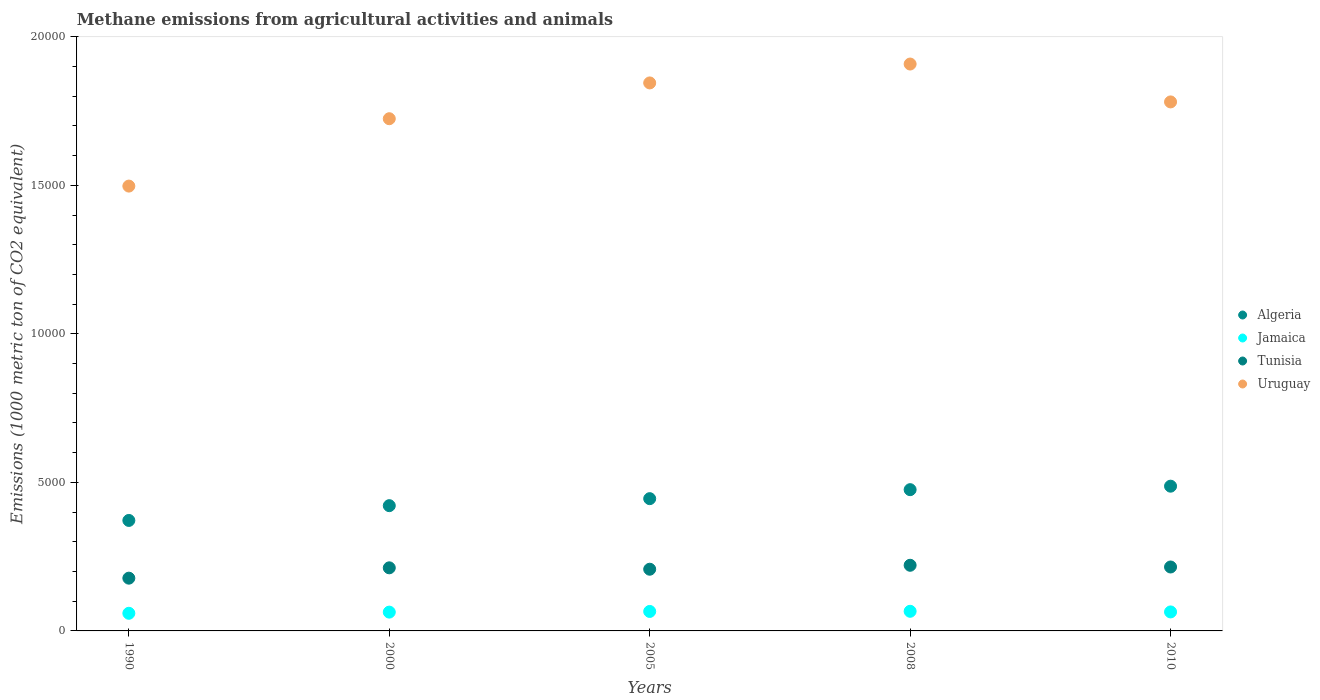What is the amount of methane emitted in Tunisia in 2010?
Offer a very short reply. 2151.9. Across all years, what is the maximum amount of methane emitted in Algeria?
Ensure brevity in your answer.  4872.2. Across all years, what is the minimum amount of methane emitted in Jamaica?
Your response must be concise. 593.6. In which year was the amount of methane emitted in Algeria maximum?
Ensure brevity in your answer.  2010. In which year was the amount of methane emitted in Algeria minimum?
Give a very brief answer. 1990. What is the total amount of methane emitted in Jamaica in the graph?
Provide a succinct answer. 3182.2. What is the difference between the amount of methane emitted in Algeria in 1990 and that in 2005?
Give a very brief answer. -733.2. What is the difference between the amount of methane emitted in Tunisia in 2005 and the amount of methane emitted in Jamaica in 2010?
Your answer should be very brief. 1437.5. What is the average amount of methane emitted in Tunisia per year?
Your answer should be very brief. 2067.6. In the year 1990, what is the difference between the amount of methane emitted in Algeria and amount of methane emitted in Uruguay?
Offer a very short reply. -1.13e+04. What is the ratio of the amount of methane emitted in Algeria in 1990 to that in 2005?
Offer a terse response. 0.84. Is the difference between the amount of methane emitted in Algeria in 2000 and 2010 greater than the difference between the amount of methane emitted in Uruguay in 2000 and 2010?
Provide a short and direct response. No. What is the difference between the highest and the second highest amount of methane emitted in Uruguay?
Keep it short and to the point. 635.7. What is the difference between the highest and the lowest amount of methane emitted in Jamaica?
Offer a very short reply. 67.2. In how many years, is the amount of methane emitted in Uruguay greater than the average amount of methane emitted in Uruguay taken over all years?
Provide a succinct answer. 3. Is it the case that in every year, the sum of the amount of methane emitted in Tunisia and amount of methane emitted in Jamaica  is greater than the sum of amount of methane emitted in Uruguay and amount of methane emitted in Algeria?
Your answer should be compact. No. Does the amount of methane emitted in Jamaica monotonically increase over the years?
Offer a very short reply. No. How many years are there in the graph?
Offer a terse response. 5. Does the graph contain grids?
Provide a succinct answer. No. Where does the legend appear in the graph?
Your response must be concise. Center right. How are the legend labels stacked?
Provide a short and direct response. Vertical. What is the title of the graph?
Give a very brief answer. Methane emissions from agricultural activities and animals. What is the label or title of the X-axis?
Keep it short and to the point. Years. What is the label or title of the Y-axis?
Ensure brevity in your answer.  Emissions (1000 metric ton of CO2 equivalent). What is the Emissions (1000 metric ton of CO2 equivalent) in Algeria in 1990?
Your response must be concise. 3718.9. What is the Emissions (1000 metric ton of CO2 equivalent) in Jamaica in 1990?
Ensure brevity in your answer.  593.6. What is the Emissions (1000 metric ton of CO2 equivalent) in Tunisia in 1990?
Offer a terse response. 1775.7. What is the Emissions (1000 metric ton of CO2 equivalent) in Uruguay in 1990?
Make the answer very short. 1.50e+04. What is the Emissions (1000 metric ton of CO2 equivalent) of Algeria in 2000?
Your answer should be compact. 4216.3. What is the Emissions (1000 metric ton of CO2 equivalent) of Jamaica in 2000?
Give a very brief answer. 632.9. What is the Emissions (1000 metric ton of CO2 equivalent) of Tunisia in 2000?
Make the answer very short. 2123.8. What is the Emissions (1000 metric ton of CO2 equivalent) in Uruguay in 2000?
Keep it short and to the point. 1.72e+04. What is the Emissions (1000 metric ton of CO2 equivalent) of Algeria in 2005?
Offer a very short reply. 4452.1. What is the Emissions (1000 metric ton of CO2 equivalent) in Jamaica in 2005?
Provide a succinct answer. 655.6. What is the Emissions (1000 metric ton of CO2 equivalent) of Tunisia in 2005?
Provide a succinct answer. 2076.8. What is the Emissions (1000 metric ton of CO2 equivalent) in Uruguay in 2005?
Give a very brief answer. 1.84e+04. What is the Emissions (1000 metric ton of CO2 equivalent) in Algeria in 2008?
Provide a short and direct response. 4754.7. What is the Emissions (1000 metric ton of CO2 equivalent) in Jamaica in 2008?
Your answer should be compact. 660.8. What is the Emissions (1000 metric ton of CO2 equivalent) in Tunisia in 2008?
Ensure brevity in your answer.  2209.8. What is the Emissions (1000 metric ton of CO2 equivalent) of Uruguay in 2008?
Provide a succinct answer. 1.91e+04. What is the Emissions (1000 metric ton of CO2 equivalent) in Algeria in 2010?
Offer a terse response. 4872.2. What is the Emissions (1000 metric ton of CO2 equivalent) in Jamaica in 2010?
Offer a terse response. 639.3. What is the Emissions (1000 metric ton of CO2 equivalent) in Tunisia in 2010?
Your answer should be very brief. 2151.9. What is the Emissions (1000 metric ton of CO2 equivalent) in Uruguay in 2010?
Provide a succinct answer. 1.78e+04. Across all years, what is the maximum Emissions (1000 metric ton of CO2 equivalent) of Algeria?
Provide a succinct answer. 4872.2. Across all years, what is the maximum Emissions (1000 metric ton of CO2 equivalent) in Jamaica?
Give a very brief answer. 660.8. Across all years, what is the maximum Emissions (1000 metric ton of CO2 equivalent) in Tunisia?
Give a very brief answer. 2209.8. Across all years, what is the maximum Emissions (1000 metric ton of CO2 equivalent) of Uruguay?
Offer a terse response. 1.91e+04. Across all years, what is the minimum Emissions (1000 metric ton of CO2 equivalent) in Algeria?
Keep it short and to the point. 3718.9. Across all years, what is the minimum Emissions (1000 metric ton of CO2 equivalent) in Jamaica?
Keep it short and to the point. 593.6. Across all years, what is the minimum Emissions (1000 metric ton of CO2 equivalent) of Tunisia?
Your answer should be compact. 1775.7. Across all years, what is the minimum Emissions (1000 metric ton of CO2 equivalent) of Uruguay?
Provide a short and direct response. 1.50e+04. What is the total Emissions (1000 metric ton of CO2 equivalent) of Algeria in the graph?
Offer a very short reply. 2.20e+04. What is the total Emissions (1000 metric ton of CO2 equivalent) in Jamaica in the graph?
Provide a succinct answer. 3182.2. What is the total Emissions (1000 metric ton of CO2 equivalent) of Tunisia in the graph?
Your answer should be very brief. 1.03e+04. What is the total Emissions (1000 metric ton of CO2 equivalent) of Uruguay in the graph?
Provide a short and direct response. 8.75e+04. What is the difference between the Emissions (1000 metric ton of CO2 equivalent) of Algeria in 1990 and that in 2000?
Ensure brevity in your answer.  -497.4. What is the difference between the Emissions (1000 metric ton of CO2 equivalent) of Jamaica in 1990 and that in 2000?
Provide a short and direct response. -39.3. What is the difference between the Emissions (1000 metric ton of CO2 equivalent) in Tunisia in 1990 and that in 2000?
Your answer should be compact. -348.1. What is the difference between the Emissions (1000 metric ton of CO2 equivalent) of Uruguay in 1990 and that in 2000?
Ensure brevity in your answer.  -2267.7. What is the difference between the Emissions (1000 metric ton of CO2 equivalent) in Algeria in 1990 and that in 2005?
Make the answer very short. -733.2. What is the difference between the Emissions (1000 metric ton of CO2 equivalent) of Jamaica in 1990 and that in 2005?
Keep it short and to the point. -62. What is the difference between the Emissions (1000 metric ton of CO2 equivalent) in Tunisia in 1990 and that in 2005?
Your answer should be very brief. -301.1. What is the difference between the Emissions (1000 metric ton of CO2 equivalent) of Uruguay in 1990 and that in 2005?
Your answer should be very brief. -3472.5. What is the difference between the Emissions (1000 metric ton of CO2 equivalent) in Algeria in 1990 and that in 2008?
Give a very brief answer. -1035.8. What is the difference between the Emissions (1000 metric ton of CO2 equivalent) of Jamaica in 1990 and that in 2008?
Provide a succinct answer. -67.2. What is the difference between the Emissions (1000 metric ton of CO2 equivalent) in Tunisia in 1990 and that in 2008?
Offer a terse response. -434.1. What is the difference between the Emissions (1000 metric ton of CO2 equivalent) in Uruguay in 1990 and that in 2008?
Offer a terse response. -4108.2. What is the difference between the Emissions (1000 metric ton of CO2 equivalent) in Algeria in 1990 and that in 2010?
Keep it short and to the point. -1153.3. What is the difference between the Emissions (1000 metric ton of CO2 equivalent) in Jamaica in 1990 and that in 2010?
Give a very brief answer. -45.7. What is the difference between the Emissions (1000 metric ton of CO2 equivalent) in Tunisia in 1990 and that in 2010?
Make the answer very short. -376.2. What is the difference between the Emissions (1000 metric ton of CO2 equivalent) in Uruguay in 1990 and that in 2010?
Provide a short and direct response. -2833.1. What is the difference between the Emissions (1000 metric ton of CO2 equivalent) of Algeria in 2000 and that in 2005?
Keep it short and to the point. -235.8. What is the difference between the Emissions (1000 metric ton of CO2 equivalent) of Jamaica in 2000 and that in 2005?
Your response must be concise. -22.7. What is the difference between the Emissions (1000 metric ton of CO2 equivalent) in Tunisia in 2000 and that in 2005?
Keep it short and to the point. 47. What is the difference between the Emissions (1000 metric ton of CO2 equivalent) in Uruguay in 2000 and that in 2005?
Keep it short and to the point. -1204.8. What is the difference between the Emissions (1000 metric ton of CO2 equivalent) in Algeria in 2000 and that in 2008?
Your response must be concise. -538.4. What is the difference between the Emissions (1000 metric ton of CO2 equivalent) in Jamaica in 2000 and that in 2008?
Offer a very short reply. -27.9. What is the difference between the Emissions (1000 metric ton of CO2 equivalent) in Tunisia in 2000 and that in 2008?
Offer a terse response. -86. What is the difference between the Emissions (1000 metric ton of CO2 equivalent) of Uruguay in 2000 and that in 2008?
Provide a short and direct response. -1840.5. What is the difference between the Emissions (1000 metric ton of CO2 equivalent) of Algeria in 2000 and that in 2010?
Give a very brief answer. -655.9. What is the difference between the Emissions (1000 metric ton of CO2 equivalent) in Jamaica in 2000 and that in 2010?
Your response must be concise. -6.4. What is the difference between the Emissions (1000 metric ton of CO2 equivalent) of Tunisia in 2000 and that in 2010?
Offer a terse response. -28.1. What is the difference between the Emissions (1000 metric ton of CO2 equivalent) of Uruguay in 2000 and that in 2010?
Ensure brevity in your answer.  -565.4. What is the difference between the Emissions (1000 metric ton of CO2 equivalent) of Algeria in 2005 and that in 2008?
Ensure brevity in your answer.  -302.6. What is the difference between the Emissions (1000 metric ton of CO2 equivalent) in Tunisia in 2005 and that in 2008?
Make the answer very short. -133. What is the difference between the Emissions (1000 metric ton of CO2 equivalent) of Uruguay in 2005 and that in 2008?
Your response must be concise. -635.7. What is the difference between the Emissions (1000 metric ton of CO2 equivalent) in Algeria in 2005 and that in 2010?
Offer a terse response. -420.1. What is the difference between the Emissions (1000 metric ton of CO2 equivalent) in Jamaica in 2005 and that in 2010?
Provide a succinct answer. 16.3. What is the difference between the Emissions (1000 metric ton of CO2 equivalent) of Tunisia in 2005 and that in 2010?
Offer a very short reply. -75.1. What is the difference between the Emissions (1000 metric ton of CO2 equivalent) in Uruguay in 2005 and that in 2010?
Give a very brief answer. 639.4. What is the difference between the Emissions (1000 metric ton of CO2 equivalent) in Algeria in 2008 and that in 2010?
Offer a terse response. -117.5. What is the difference between the Emissions (1000 metric ton of CO2 equivalent) in Tunisia in 2008 and that in 2010?
Keep it short and to the point. 57.9. What is the difference between the Emissions (1000 metric ton of CO2 equivalent) of Uruguay in 2008 and that in 2010?
Your answer should be very brief. 1275.1. What is the difference between the Emissions (1000 metric ton of CO2 equivalent) in Algeria in 1990 and the Emissions (1000 metric ton of CO2 equivalent) in Jamaica in 2000?
Give a very brief answer. 3086. What is the difference between the Emissions (1000 metric ton of CO2 equivalent) in Algeria in 1990 and the Emissions (1000 metric ton of CO2 equivalent) in Tunisia in 2000?
Make the answer very short. 1595.1. What is the difference between the Emissions (1000 metric ton of CO2 equivalent) of Algeria in 1990 and the Emissions (1000 metric ton of CO2 equivalent) of Uruguay in 2000?
Offer a terse response. -1.35e+04. What is the difference between the Emissions (1000 metric ton of CO2 equivalent) in Jamaica in 1990 and the Emissions (1000 metric ton of CO2 equivalent) in Tunisia in 2000?
Provide a short and direct response. -1530.2. What is the difference between the Emissions (1000 metric ton of CO2 equivalent) of Jamaica in 1990 and the Emissions (1000 metric ton of CO2 equivalent) of Uruguay in 2000?
Your answer should be very brief. -1.66e+04. What is the difference between the Emissions (1000 metric ton of CO2 equivalent) of Tunisia in 1990 and the Emissions (1000 metric ton of CO2 equivalent) of Uruguay in 2000?
Offer a terse response. -1.55e+04. What is the difference between the Emissions (1000 metric ton of CO2 equivalent) in Algeria in 1990 and the Emissions (1000 metric ton of CO2 equivalent) in Jamaica in 2005?
Your answer should be very brief. 3063.3. What is the difference between the Emissions (1000 metric ton of CO2 equivalent) in Algeria in 1990 and the Emissions (1000 metric ton of CO2 equivalent) in Tunisia in 2005?
Your response must be concise. 1642.1. What is the difference between the Emissions (1000 metric ton of CO2 equivalent) of Algeria in 1990 and the Emissions (1000 metric ton of CO2 equivalent) of Uruguay in 2005?
Provide a succinct answer. -1.47e+04. What is the difference between the Emissions (1000 metric ton of CO2 equivalent) in Jamaica in 1990 and the Emissions (1000 metric ton of CO2 equivalent) in Tunisia in 2005?
Give a very brief answer. -1483.2. What is the difference between the Emissions (1000 metric ton of CO2 equivalent) in Jamaica in 1990 and the Emissions (1000 metric ton of CO2 equivalent) in Uruguay in 2005?
Your answer should be very brief. -1.79e+04. What is the difference between the Emissions (1000 metric ton of CO2 equivalent) of Tunisia in 1990 and the Emissions (1000 metric ton of CO2 equivalent) of Uruguay in 2005?
Provide a short and direct response. -1.67e+04. What is the difference between the Emissions (1000 metric ton of CO2 equivalent) in Algeria in 1990 and the Emissions (1000 metric ton of CO2 equivalent) in Jamaica in 2008?
Provide a short and direct response. 3058.1. What is the difference between the Emissions (1000 metric ton of CO2 equivalent) of Algeria in 1990 and the Emissions (1000 metric ton of CO2 equivalent) of Tunisia in 2008?
Your answer should be compact. 1509.1. What is the difference between the Emissions (1000 metric ton of CO2 equivalent) of Algeria in 1990 and the Emissions (1000 metric ton of CO2 equivalent) of Uruguay in 2008?
Your response must be concise. -1.54e+04. What is the difference between the Emissions (1000 metric ton of CO2 equivalent) of Jamaica in 1990 and the Emissions (1000 metric ton of CO2 equivalent) of Tunisia in 2008?
Offer a very short reply. -1616.2. What is the difference between the Emissions (1000 metric ton of CO2 equivalent) in Jamaica in 1990 and the Emissions (1000 metric ton of CO2 equivalent) in Uruguay in 2008?
Give a very brief answer. -1.85e+04. What is the difference between the Emissions (1000 metric ton of CO2 equivalent) in Tunisia in 1990 and the Emissions (1000 metric ton of CO2 equivalent) in Uruguay in 2008?
Your response must be concise. -1.73e+04. What is the difference between the Emissions (1000 metric ton of CO2 equivalent) in Algeria in 1990 and the Emissions (1000 metric ton of CO2 equivalent) in Jamaica in 2010?
Make the answer very short. 3079.6. What is the difference between the Emissions (1000 metric ton of CO2 equivalent) of Algeria in 1990 and the Emissions (1000 metric ton of CO2 equivalent) of Tunisia in 2010?
Your answer should be compact. 1567. What is the difference between the Emissions (1000 metric ton of CO2 equivalent) of Algeria in 1990 and the Emissions (1000 metric ton of CO2 equivalent) of Uruguay in 2010?
Provide a succinct answer. -1.41e+04. What is the difference between the Emissions (1000 metric ton of CO2 equivalent) in Jamaica in 1990 and the Emissions (1000 metric ton of CO2 equivalent) in Tunisia in 2010?
Your answer should be compact. -1558.3. What is the difference between the Emissions (1000 metric ton of CO2 equivalent) of Jamaica in 1990 and the Emissions (1000 metric ton of CO2 equivalent) of Uruguay in 2010?
Your answer should be compact. -1.72e+04. What is the difference between the Emissions (1000 metric ton of CO2 equivalent) in Tunisia in 1990 and the Emissions (1000 metric ton of CO2 equivalent) in Uruguay in 2010?
Your response must be concise. -1.60e+04. What is the difference between the Emissions (1000 metric ton of CO2 equivalent) of Algeria in 2000 and the Emissions (1000 metric ton of CO2 equivalent) of Jamaica in 2005?
Make the answer very short. 3560.7. What is the difference between the Emissions (1000 metric ton of CO2 equivalent) of Algeria in 2000 and the Emissions (1000 metric ton of CO2 equivalent) of Tunisia in 2005?
Your answer should be compact. 2139.5. What is the difference between the Emissions (1000 metric ton of CO2 equivalent) in Algeria in 2000 and the Emissions (1000 metric ton of CO2 equivalent) in Uruguay in 2005?
Give a very brief answer. -1.42e+04. What is the difference between the Emissions (1000 metric ton of CO2 equivalent) in Jamaica in 2000 and the Emissions (1000 metric ton of CO2 equivalent) in Tunisia in 2005?
Offer a terse response. -1443.9. What is the difference between the Emissions (1000 metric ton of CO2 equivalent) in Jamaica in 2000 and the Emissions (1000 metric ton of CO2 equivalent) in Uruguay in 2005?
Offer a terse response. -1.78e+04. What is the difference between the Emissions (1000 metric ton of CO2 equivalent) of Tunisia in 2000 and the Emissions (1000 metric ton of CO2 equivalent) of Uruguay in 2005?
Make the answer very short. -1.63e+04. What is the difference between the Emissions (1000 metric ton of CO2 equivalent) of Algeria in 2000 and the Emissions (1000 metric ton of CO2 equivalent) of Jamaica in 2008?
Your answer should be very brief. 3555.5. What is the difference between the Emissions (1000 metric ton of CO2 equivalent) of Algeria in 2000 and the Emissions (1000 metric ton of CO2 equivalent) of Tunisia in 2008?
Offer a very short reply. 2006.5. What is the difference between the Emissions (1000 metric ton of CO2 equivalent) in Algeria in 2000 and the Emissions (1000 metric ton of CO2 equivalent) in Uruguay in 2008?
Offer a very short reply. -1.49e+04. What is the difference between the Emissions (1000 metric ton of CO2 equivalent) of Jamaica in 2000 and the Emissions (1000 metric ton of CO2 equivalent) of Tunisia in 2008?
Give a very brief answer. -1576.9. What is the difference between the Emissions (1000 metric ton of CO2 equivalent) in Jamaica in 2000 and the Emissions (1000 metric ton of CO2 equivalent) in Uruguay in 2008?
Keep it short and to the point. -1.84e+04. What is the difference between the Emissions (1000 metric ton of CO2 equivalent) in Tunisia in 2000 and the Emissions (1000 metric ton of CO2 equivalent) in Uruguay in 2008?
Give a very brief answer. -1.70e+04. What is the difference between the Emissions (1000 metric ton of CO2 equivalent) in Algeria in 2000 and the Emissions (1000 metric ton of CO2 equivalent) in Jamaica in 2010?
Provide a succinct answer. 3577. What is the difference between the Emissions (1000 metric ton of CO2 equivalent) of Algeria in 2000 and the Emissions (1000 metric ton of CO2 equivalent) of Tunisia in 2010?
Provide a short and direct response. 2064.4. What is the difference between the Emissions (1000 metric ton of CO2 equivalent) in Algeria in 2000 and the Emissions (1000 metric ton of CO2 equivalent) in Uruguay in 2010?
Offer a very short reply. -1.36e+04. What is the difference between the Emissions (1000 metric ton of CO2 equivalent) in Jamaica in 2000 and the Emissions (1000 metric ton of CO2 equivalent) in Tunisia in 2010?
Ensure brevity in your answer.  -1519. What is the difference between the Emissions (1000 metric ton of CO2 equivalent) in Jamaica in 2000 and the Emissions (1000 metric ton of CO2 equivalent) in Uruguay in 2010?
Provide a succinct answer. -1.72e+04. What is the difference between the Emissions (1000 metric ton of CO2 equivalent) of Tunisia in 2000 and the Emissions (1000 metric ton of CO2 equivalent) of Uruguay in 2010?
Ensure brevity in your answer.  -1.57e+04. What is the difference between the Emissions (1000 metric ton of CO2 equivalent) of Algeria in 2005 and the Emissions (1000 metric ton of CO2 equivalent) of Jamaica in 2008?
Provide a succinct answer. 3791.3. What is the difference between the Emissions (1000 metric ton of CO2 equivalent) of Algeria in 2005 and the Emissions (1000 metric ton of CO2 equivalent) of Tunisia in 2008?
Your response must be concise. 2242.3. What is the difference between the Emissions (1000 metric ton of CO2 equivalent) in Algeria in 2005 and the Emissions (1000 metric ton of CO2 equivalent) in Uruguay in 2008?
Give a very brief answer. -1.46e+04. What is the difference between the Emissions (1000 metric ton of CO2 equivalent) of Jamaica in 2005 and the Emissions (1000 metric ton of CO2 equivalent) of Tunisia in 2008?
Your answer should be compact. -1554.2. What is the difference between the Emissions (1000 metric ton of CO2 equivalent) in Jamaica in 2005 and the Emissions (1000 metric ton of CO2 equivalent) in Uruguay in 2008?
Offer a terse response. -1.84e+04. What is the difference between the Emissions (1000 metric ton of CO2 equivalent) of Tunisia in 2005 and the Emissions (1000 metric ton of CO2 equivalent) of Uruguay in 2008?
Provide a short and direct response. -1.70e+04. What is the difference between the Emissions (1000 metric ton of CO2 equivalent) in Algeria in 2005 and the Emissions (1000 metric ton of CO2 equivalent) in Jamaica in 2010?
Offer a terse response. 3812.8. What is the difference between the Emissions (1000 metric ton of CO2 equivalent) in Algeria in 2005 and the Emissions (1000 metric ton of CO2 equivalent) in Tunisia in 2010?
Ensure brevity in your answer.  2300.2. What is the difference between the Emissions (1000 metric ton of CO2 equivalent) of Algeria in 2005 and the Emissions (1000 metric ton of CO2 equivalent) of Uruguay in 2010?
Provide a succinct answer. -1.34e+04. What is the difference between the Emissions (1000 metric ton of CO2 equivalent) in Jamaica in 2005 and the Emissions (1000 metric ton of CO2 equivalent) in Tunisia in 2010?
Ensure brevity in your answer.  -1496.3. What is the difference between the Emissions (1000 metric ton of CO2 equivalent) in Jamaica in 2005 and the Emissions (1000 metric ton of CO2 equivalent) in Uruguay in 2010?
Give a very brief answer. -1.72e+04. What is the difference between the Emissions (1000 metric ton of CO2 equivalent) of Tunisia in 2005 and the Emissions (1000 metric ton of CO2 equivalent) of Uruguay in 2010?
Make the answer very short. -1.57e+04. What is the difference between the Emissions (1000 metric ton of CO2 equivalent) in Algeria in 2008 and the Emissions (1000 metric ton of CO2 equivalent) in Jamaica in 2010?
Ensure brevity in your answer.  4115.4. What is the difference between the Emissions (1000 metric ton of CO2 equivalent) of Algeria in 2008 and the Emissions (1000 metric ton of CO2 equivalent) of Tunisia in 2010?
Provide a succinct answer. 2602.8. What is the difference between the Emissions (1000 metric ton of CO2 equivalent) in Algeria in 2008 and the Emissions (1000 metric ton of CO2 equivalent) in Uruguay in 2010?
Keep it short and to the point. -1.31e+04. What is the difference between the Emissions (1000 metric ton of CO2 equivalent) in Jamaica in 2008 and the Emissions (1000 metric ton of CO2 equivalent) in Tunisia in 2010?
Make the answer very short. -1491.1. What is the difference between the Emissions (1000 metric ton of CO2 equivalent) of Jamaica in 2008 and the Emissions (1000 metric ton of CO2 equivalent) of Uruguay in 2010?
Give a very brief answer. -1.71e+04. What is the difference between the Emissions (1000 metric ton of CO2 equivalent) in Tunisia in 2008 and the Emissions (1000 metric ton of CO2 equivalent) in Uruguay in 2010?
Offer a very short reply. -1.56e+04. What is the average Emissions (1000 metric ton of CO2 equivalent) in Algeria per year?
Make the answer very short. 4402.84. What is the average Emissions (1000 metric ton of CO2 equivalent) of Jamaica per year?
Give a very brief answer. 636.44. What is the average Emissions (1000 metric ton of CO2 equivalent) in Tunisia per year?
Offer a terse response. 2067.6. What is the average Emissions (1000 metric ton of CO2 equivalent) of Uruguay per year?
Ensure brevity in your answer.  1.75e+04. In the year 1990, what is the difference between the Emissions (1000 metric ton of CO2 equivalent) of Algeria and Emissions (1000 metric ton of CO2 equivalent) of Jamaica?
Provide a succinct answer. 3125.3. In the year 1990, what is the difference between the Emissions (1000 metric ton of CO2 equivalent) in Algeria and Emissions (1000 metric ton of CO2 equivalent) in Tunisia?
Your answer should be very brief. 1943.2. In the year 1990, what is the difference between the Emissions (1000 metric ton of CO2 equivalent) of Algeria and Emissions (1000 metric ton of CO2 equivalent) of Uruguay?
Your answer should be very brief. -1.13e+04. In the year 1990, what is the difference between the Emissions (1000 metric ton of CO2 equivalent) of Jamaica and Emissions (1000 metric ton of CO2 equivalent) of Tunisia?
Provide a short and direct response. -1182.1. In the year 1990, what is the difference between the Emissions (1000 metric ton of CO2 equivalent) of Jamaica and Emissions (1000 metric ton of CO2 equivalent) of Uruguay?
Provide a short and direct response. -1.44e+04. In the year 1990, what is the difference between the Emissions (1000 metric ton of CO2 equivalent) in Tunisia and Emissions (1000 metric ton of CO2 equivalent) in Uruguay?
Keep it short and to the point. -1.32e+04. In the year 2000, what is the difference between the Emissions (1000 metric ton of CO2 equivalent) of Algeria and Emissions (1000 metric ton of CO2 equivalent) of Jamaica?
Your response must be concise. 3583.4. In the year 2000, what is the difference between the Emissions (1000 metric ton of CO2 equivalent) in Algeria and Emissions (1000 metric ton of CO2 equivalent) in Tunisia?
Provide a short and direct response. 2092.5. In the year 2000, what is the difference between the Emissions (1000 metric ton of CO2 equivalent) in Algeria and Emissions (1000 metric ton of CO2 equivalent) in Uruguay?
Your answer should be very brief. -1.30e+04. In the year 2000, what is the difference between the Emissions (1000 metric ton of CO2 equivalent) in Jamaica and Emissions (1000 metric ton of CO2 equivalent) in Tunisia?
Your response must be concise. -1490.9. In the year 2000, what is the difference between the Emissions (1000 metric ton of CO2 equivalent) of Jamaica and Emissions (1000 metric ton of CO2 equivalent) of Uruguay?
Offer a terse response. -1.66e+04. In the year 2000, what is the difference between the Emissions (1000 metric ton of CO2 equivalent) in Tunisia and Emissions (1000 metric ton of CO2 equivalent) in Uruguay?
Provide a short and direct response. -1.51e+04. In the year 2005, what is the difference between the Emissions (1000 metric ton of CO2 equivalent) in Algeria and Emissions (1000 metric ton of CO2 equivalent) in Jamaica?
Provide a succinct answer. 3796.5. In the year 2005, what is the difference between the Emissions (1000 metric ton of CO2 equivalent) in Algeria and Emissions (1000 metric ton of CO2 equivalent) in Tunisia?
Your answer should be compact. 2375.3. In the year 2005, what is the difference between the Emissions (1000 metric ton of CO2 equivalent) of Algeria and Emissions (1000 metric ton of CO2 equivalent) of Uruguay?
Make the answer very short. -1.40e+04. In the year 2005, what is the difference between the Emissions (1000 metric ton of CO2 equivalent) of Jamaica and Emissions (1000 metric ton of CO2 equivalent) of Tunisia?
Offer a terse response. -1421.2. In the year 2005, what is the difference between the Emissions (1000 metric ton of CO2 equivalent) in Jamaica and Emissions (1000 metric ton of CO2 equivalent) in Uruguay?
Offer a terse response. -1.78e+04. In the year 2005, what is the difference between the Emissions (1000 metric ton of CO2 equivalent) of Tunisia and Emissions (1000 metric ton of CO2 equivalent) of Uruguay?
Your answer should be compact. -1.64e+04. In the year 2008, what is the difference between the Emissions (1000 metric ton of CO2 equivalent) of Algeria and Emissions (1000 metric ton of CO2 equivalent) of Jamaica?
Give a very brief answer. 4093.9. In the year 2008, what is the difference between the Emissions (1000 metric ton of CO2 equivalent) in Algeria and Emissions (1000 metric ton of CO2 equivalent) in Tunisia?
Your answer should be compact. 2544.9. In the year 2008, what is the difference between the Emissions (1000 metric ton of CO2 equivalent) of Algeria and Emissions (1000 metric ton of CO2 equivalent) of Uruguay?
Provide a short and direct response. -1.43e+04. In the year 2008, what is the difference between the Emissions (1000 metric ton of CO2 equivalent) of Jamaica and Emissions (1000 metric ton of CO2 equivalent) of Tunisia?
Keep it short and to the point. -1549. In the year 2008, what is the difference between the Emissions (1000 metric ton of CO2 equivalent) of Jamaica and Emissions (1000 metric ton of CO2 equivalent) of Uruguay?
Provide a short and direct response. -1.84e+04. In the year 2008, what is the difference between the Emissions (1000 metric ton of CO2 equivalent) in Tunisia and Emissions (1000 metric ton of CO2 equivalent) in Uruguay?
Ensure brevity in your answer.  -1.69e+04. In the year 2010, what is the difference between the Emissions (1000 metric ton of CO2 equivalent) of Algeria and Emissions (1000 metric ton of CO2 equivalent) of Jamaica?
Your answer should be compact. 4232.9. In the year 2010, what is the difference between the Emissions (1000 metric ton of CO2 equivalent) in Algeria and Emissions (1000 metric ton of CO2 equivalent) in Tunisia?
Provide a succinct answer. 2720.3. In the year 2010, what is the difference between the Emissions (1000 metric ton of CO2 equivalent) of Algeria and Emissions (1000 metric ton of CO2 equivalent) of Uruguay?
Make the answer very short. -1.29e+04. In the year 2010, what is the difference between the Emissions (1000 metric ton of CO2 equivalent) in Jamaica and Emissions (1000 metric ton of CO2 equivalent) in Tunisia?
Give a very brief answer. -1512.6. In the year 2010, what is the difference between the Emissions (1000 metric ton of CO2 equivalent) of Jamaica and Emissions (1000 metric ton of CO2 equivalent) of Uruguay?
Give a very brief answer. -1.72e+04. In the year 2010, what is the difference between the Emissions (1000 metric ton of CO2 equivalent) in Tunisia and Emissions (1000 metric ton of CO2 equivalent) in Uruguay?
Give a very brief answer. -1.57e+04. What is the ratio of the Emissions (1000 metric ton of CO2 equivalent) of Algeria in 1990 to that in 2000?
Provide a succinct answer. 0.88. What is the ratio of the Emissions (1000 metric ton of CO2 equivalent) in Jamaica in 1990 to that in 2000?
Offer a very short reply. 0.94. What is the ratio of the Emissions (1000 metric ton of CO2 equivalent) in Tunisia in 1990 to that in 2000?
Your response must be concise. 0.84. What is the ratio of the Emissions (1000 metric ton of CO2 equivalent) in Uruguay in 1990 to that in 2000?
Make the answer very short. 0.87. What is the ratio of the Emissions (1000 metric ton of CO2 equivalent) in Algeria in 1990 to that in 2005?
Offer a very short reply. 0.84. What is the ratio of the Emissions (1000 metric ton of CO2 equivalent) in Jamaica in 1990 to that in 2005?
Provide a short and direct response. 0.91. What is the ratio of the Emissions (1000 metric ton of CO2 equivalent) in Tunisia in 1990 to that in 2005?
Your answer should be very brief. 0.85. What is the ratio of the Emissions (1000 metric ton of CO2 equivalent) in Uruguay in 1990 to that in 2005?
Your answer should be very brief. 0.81. What is the ratio of the Emissions (1000 metric ton of CO2 equivalent) in Algeria in 1990 to that in 2008?
Ensure brevity in your answer.  0.78. What is the ratio of the Emissions (1000 metric ton of CO2 equivalent) in Jamaica in 1990 to that in 2008?
Make the answer very short. 0.9. What is the ratio of the Emissions (1000 metric ton of CO2 equivalent) of Tunisia in 1990 to that in 2008?
Ensure brevity in your answer.  0.8. What is the ratio of the Emissions (1000 metric ton of CO2 equivalent) of Uruguay in 1990 to that in 2008?
Give a very brief answer. 0.78. What is the ratio of the Emissions (1000 metric ton of CO2 equivalent) in Algeria in 1990 to that in 2010?
Ensure brevity in your answer.  0.76. What is the ratio of the Emissions (1000 metric ton of CO2 equivalent) of Jamaica in 1990 to that in 2010?
Offer a very short reply. 0.93. What is the ratio of the Emissions (1000 metric ton of CO2 equivalent) of Tunisia in 1990 to that in 2010?
Offer a very short reply. 0.83. What is the ratio of the Emissions (1000 metric ton of CO2 equivalent) of Uruguay in 1990 to that in 2010?
Keep it short and to the point. 0.84. What is the ratio of the Emissions (1000 metric ton of CO2 equivalent) of Algeria in 2000 to that in 2005?
Keep it short and to the point. 0.95. What is the ratio of the Emissions (1000 metric ton of CO2 equivalent) of Jamaica in 2000 to that in 2005?
Your response must be concise. 0.97. What is the ratio of the Emissions (1000 metric ton of CO2 equivalent) of Tunisia in 2000 to that in 2005?
Your response must be concise. 1.02. What is the ratio of the Emissions (1000 metric ton of CO2 equivalent) of Uruguay in 2000 to that in 2005?
Give a very brief answer. 0.93. What is the ratio of the Emissions (1000 metric ton of CO2 equivalent) of Algeria in 2000 to that in 2008?
Ensure brevity in your answer.  0.89. What is the ratio of the Emissions (1000 metric ton of CO2 equivalent) in Jamaica in 2000 to that in 2008?
Your answer should be compact. 0.96. What is the ratio of the Emissions (1000 metric ton of CO2 equivalent) of Tunisia in 2000 to that in 2008?
Offer a terse response. 0.96. What is the ratio of the Emissions (1000 metric ton of CO2 equivalent) in Uruguay in 2000 to that in 2008?
Your answer should be compact. 0.9. What is the ratio of the Emissions (1000 metric ton of CO2 equivalent) in Algeria in 2000 to that in 2010?
Your answer should be very brief. 0.87. What is the ratio of the Emissions (1000 metric ton of CO2 equivalent) in Jamaica in 2000 to that in 2010?
Give a very brief answer. 0.99. What is the ratio of the Emissions (1000 metric ton of CO2 equivalent) in Tunisia in 2000 to that in 2010?
Offer a very short reply. 0.99. What is the ratio of the Emissions (1000 metric ton of CO2 equivalent) of Uruguay in 2000 to that in 2010?
Provide a short and direct response. 0.97. What is the ratio of the Emissions (1000 metric ton of CO2 equivalent) in Algeria in 2005 to that in 2008?
Give a very brief answer. 0.94. What is the ratio of the Emissions (1000 metric ton of CO2 equivalent) in Tunisia in 2005 to that in 2008?
Your response must be concise. 0.94. What is the ratio of the Emissions (1000 metric ton of CO2 equivalent) in Uruguay in 2005 to that in 2008?
Your answer should be very brief. 0.97. What is the ratio of the Emissions (1000 metric ton of CO2 equivalent) in Algeria in 2005 to that in 2010?
Your response must be concise. 0.91. What is the ratio of the Emissions (1000 metric ton of CO2 equivalent) of Jamaica in 2005 to that in 2010?
Your answer should be very brief. 1.03. What is the ratio of the Emissions (1000 metric ton of CO2 equivalent) of Tunisia in 2005 to that in 2010?
Your answer should be very brief. 0.97. What is the ratio of the Emissions (1000 metric ton of CO2 equivalent) of Uruguay in 2005 to that in 2010?
Your response must be concise. 1.04. What is the ratio of the Emissions (1000 metric ton of CO2 equivalent) of Algeria in 2008 to that in 2010?
Offer a terse response. 0.98. What is the ratio of the Emissions (1000 metric ton of CO2 equivalent) of Jamaica in 2008 to that in 2010?
Offer a very short reply. 1.03. What is the ratio of the Emissions (1000 metric ton of CO2 equivalent) of Tunisia in 2008 to that in 2010?
Your answer should be compact. 1.03. What is the ratio of the Emissions (1000 metric ton of CO2 equivalent) in Uruguay in 2008 to that in 2010?
Ensure brevity in your answer.  1.07. What is the difference between the highest and the second highest Emissions (1000 metric ton of CO2 equivalent) in Algeria?
Offer a very short reply. 117.5. What is the difference between the highest and the second highest Emissions (1000 metric ton of CO2 equivalent) of Tunisia?
Your answer should be compact. 57.9. What is the difference between the highest and the second highest Emissions (1000 metric ton of CO2 equivalent) of Uruguay?
Your answer should be compact. 635.7. What is the difference between the highest and the lowest Emissions (1000 metric ton of CO2 equivalent) of Algeria?
Your answer should be very brief. 1153.3. What is the difference between the highest and the lowest Emissions (1000 metric ton of CO2 equivalent) of Jamaica?
Keep it short and to the point. 67.2. What is the difference between the highest and the lowest Emissions (1000 metric ton of CO2 equivalent) of Tunisia?
Keep it short and to the point. 434.1. What is the difference between the highest and the lowest Emissions (1000 metric ton of CO2 equivalent) of Uruguay?
Offer a very short reply. 4108.2. 